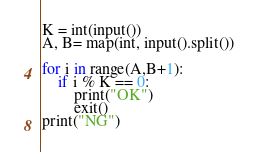Convert code to text. <code><loc_0><loc_0><loc_500><loc_500><_Python_>K = int(input())
A, B= map(int, input().split())

for i in range(A,B+1):
    if i % K == 0:
        print("OK")
        exit()
print("NG")</code> 